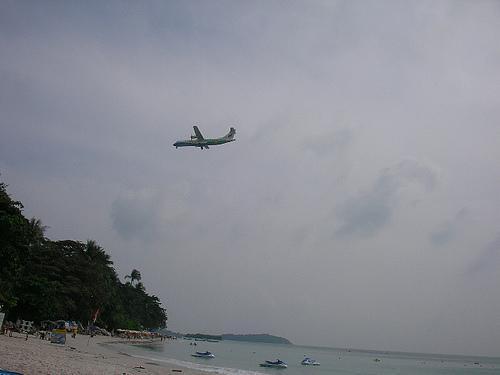How many planes are flying?
Give a very brief answer. 1. 